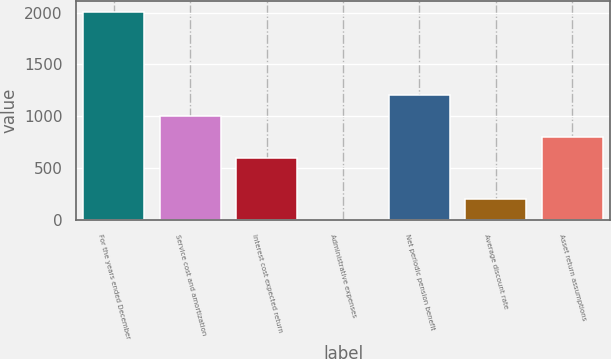Convert chart to OTSL. <chart><loc_0><loc_0><loc_500><loc_500><bar_chart><fcel>For the years ended December<fcel>Service cost and amortization<fcel>Interest cost expected return<fcel>Administrative expenses<fcel>Net periodic pension benefit<fcel>Average discount rate<fcel>Asset return assumptions<nl><fcel>2010<fcel>1005.2<fcel>603.28<fcel>0.4<fcel>1206.16<fcel>201.36<fcel>804.24<nl></chart> 